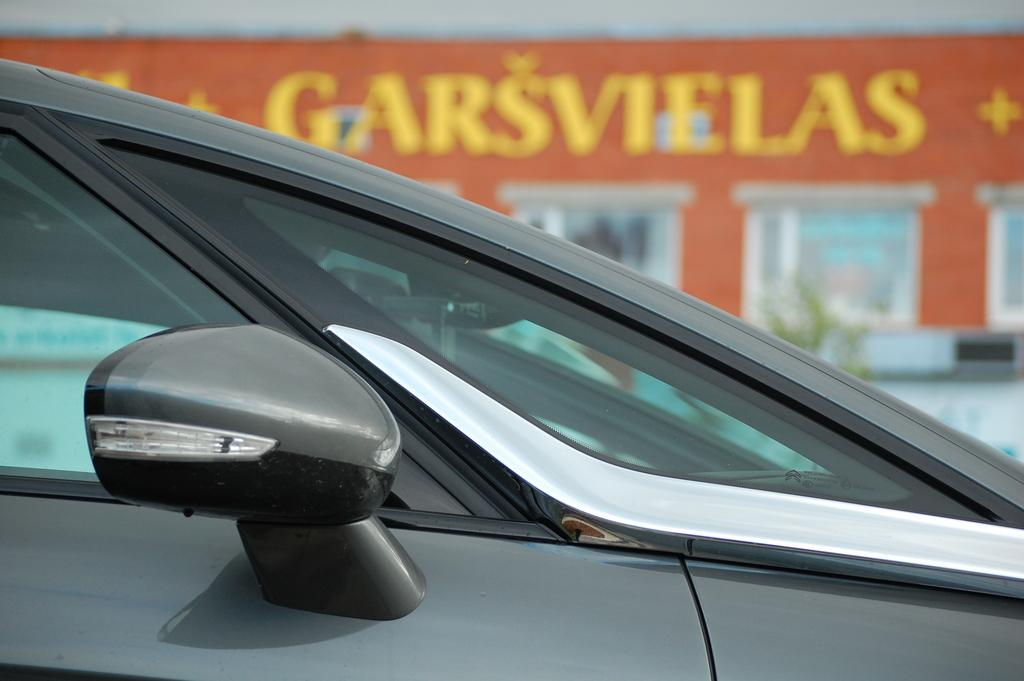What is the main subject of the image? There is a vehicle in the image. How is the vehicle depicted in the image? The vehicle appears to be truncated. Can you describe the background of the image? The background is blurred in the image. What else can be seen in the image besides the vehicle? There is a board visible in the image, as well as windows and other objects. Is there a fireman putting out a fire in the alley behind the vehicle in the image? There is no fireman or alley present in the image; it only features a vehicle with a truncated appearance and a blurred background. 